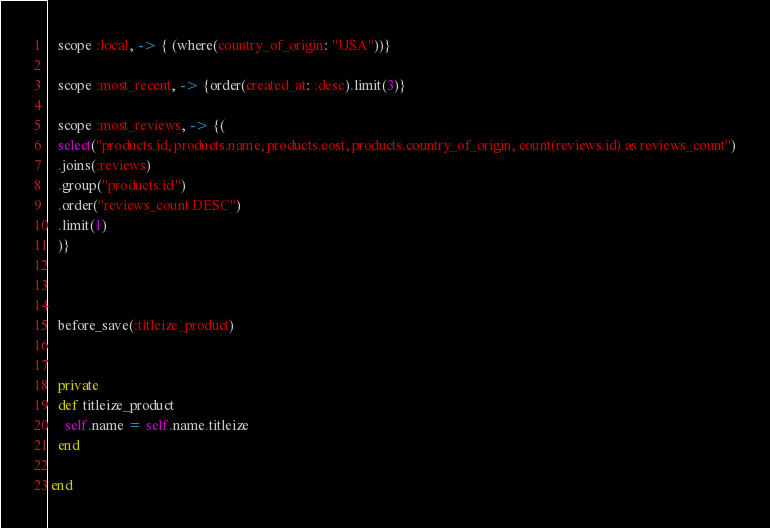<code> <loc_0><loc_0><loc_500><loc_500><_Ruby_>

   scope :local, -> { (where(country_of_origin: "USA"))}

   scope :most_recent, -> {order(created_at: :desc).limit(3)}

   scope :most_reviews, -> {(
   select("products.id, products.name, products.cost, products.country_of_origin, count(reviews.id) as reviews_count")
   .joins(:reviews)
   .group("products.id")
   .order("reviews_count DESC")
   .limit(1)
   )}



   before_save(:titleize_product)


   private
   def titleize_product
     self.name = self.name.titleize
   end

 end
</code> 